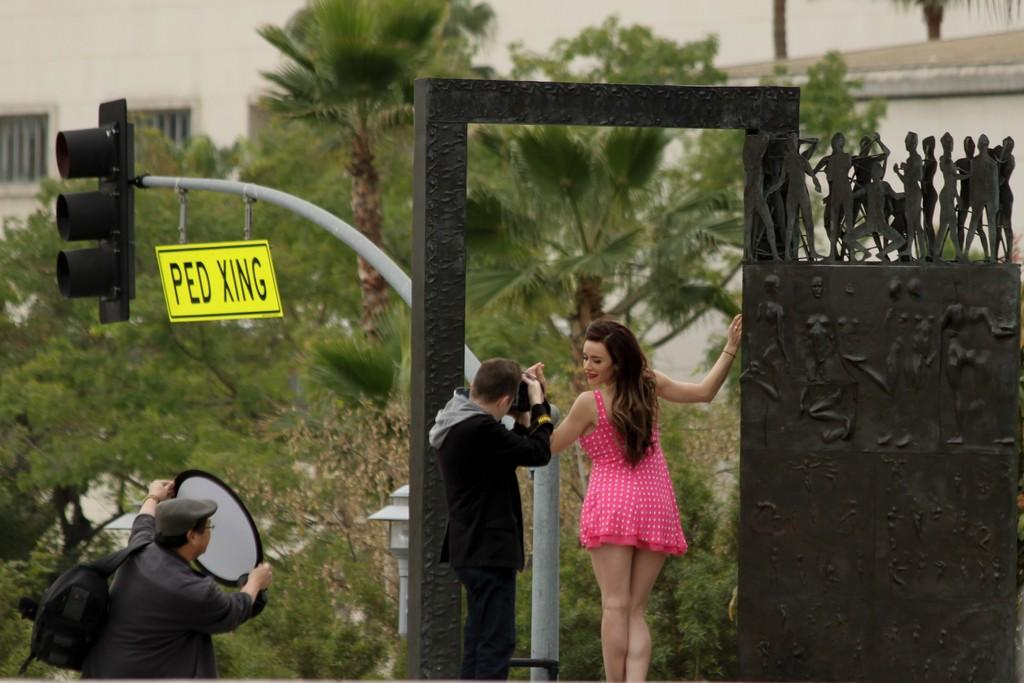What is located in the foreground of the image? There are people in the foreground of the image. What can be seen in the background of the image? There are trees, houses, and a stage set in the background of the image. What is the purpose of the pole in the background of the image? The purpose of the pole is not specified in the image, but it could be for support or decoration. What type of paper is being used to create force in the image? There is no paper or force present in the image; it features people, trees, houses, a stage set, and a pole. 